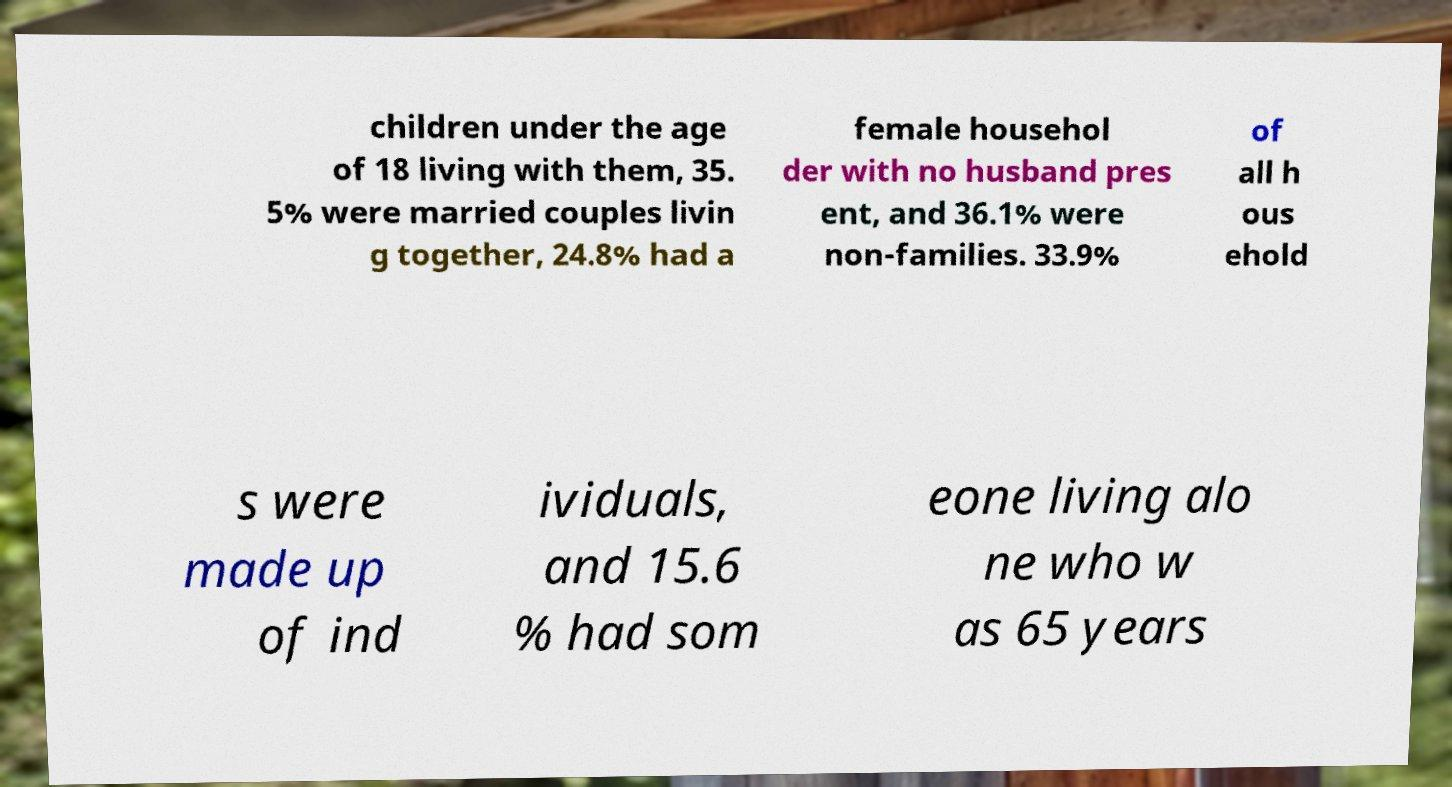Could you extract and type out the text from this image? children under the age of 18 living with them, 35. 5% were married couples livin g together, 24.8% had a female househol der with no husband pres ent, and 36.1% were non-families. 33.9% of all h ous ehold s were made up of ind ividuals, and 15.6 % had som eone living alo ne who w as 65 years 